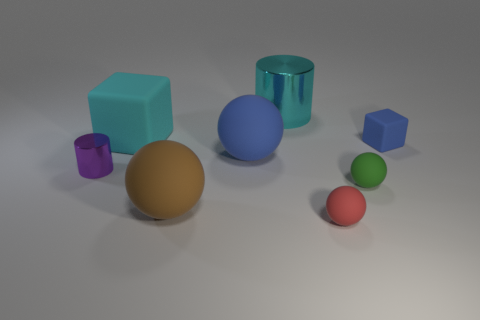Is the number of tiny matte spheres less than the number of red blocks?
Offer a very short reply. No. What number of matte balls have the same size as the purple shiny cylinder?
Provide a succinct answer. 2. There is another big object that is the same color as the big metal thing; what is its shape?
Keep it short and to the point. Cube. What is the big blue object made of?
Give a very brief answer. Rubber. There is a cylinder behind the blue rubber block; what size is it?
Provide a succinct answer. Large. What number of yellow metal things have the same shape as the small red matte object?
Offer a very short reply. 0. There is a cyan thing that is made of the same material as the red ball; what shape is it?
Give a very brief answer. Cube. How many cyan objects are either big matte things or cylinders?
Provide a succinct answer. 2. Are there any balls on the right side of the cyan metal cylinder?
Keep it short and to the point. Yes. Does the cyan metallic thing behind the purple metal object have the same shape as the tiny thing that is on the left side of the large block?
Ensure brevity in your answer.  Yes. 